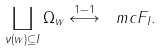Convert formula to latex. <formula><loc_0><loc_0><loc_500><loc_500>\coprod _ { \nu ( w ) \subseteq I } \Omega _ { w } \stackrel { 1 - 1 } { \longleftrightarrow } \ m c F _ { I } .</formula> 